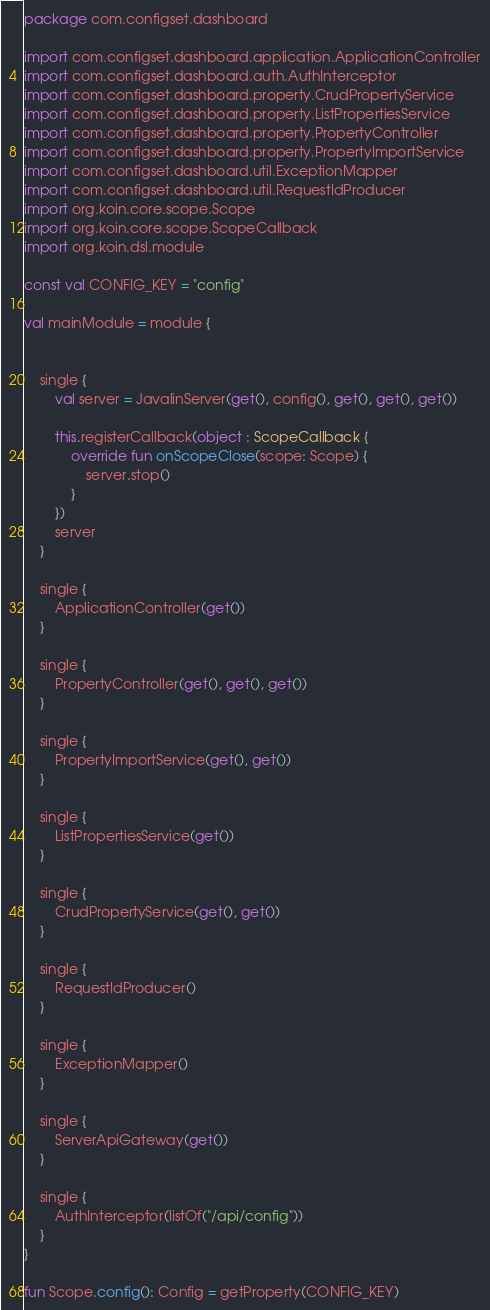Convert code to text. <code><loc_0><loc_0><loc_500><loc_500><_Kotlin_>package com.configset.dashboard

import com.configset.dashboard.application.ApplicationController
import com.configset.dashboard.auth.AuthInterceptor
import com.configset.dashboard.property.CrudPropertyService
import com.configset.dashboard.property.ListPropertiesService
import com.configset.dashboard.property.PropertyController
import com.configset.dashboard.property.PropertyImportService
import com.configset.dashboard.util.ExceptionMapper
import com.configset.dashboard.util.RequestIdProducer
import org.koin.core.scope.Scope
import org.koin.core.scope.ScopeCallback
import org.koin.dsl.module

const val CONFIG_KEY = "config"

val mainModule = module {


    single {
        val server = JavalinServer(get(), config(), get(), get(), get())

        this.registerCallback(object : ScopeCallback {
            override fun onScopeClose(scope: Scope) {
                server.stop()
            }
        })
        server
    }

    single {
        ApplicationController(get())
    }

    single {
        PropertyController(get(), get(), get())
    }

    single {
        PropertyImportService(get(), get())
    }

    single {
        ListPropertiesService(get())
    }

    single {
        CrudPropertyService(get(), get())
    }

    single {
        RequestIdProducer()
    }

    single {
        ExceptionMapper()
    }

    single {
        ServerApiGateway(get())
    }

    single {
        AuthInterceptor(listOf("/api/config"))
    }
}

fun Scope.config(): Config = getProperty(CONFIG_KEY)
</code> 